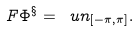<formula> <loc_0><loc_0><loc_500><loc_500>\ F { \Phi ^ { \S } } = \ u n _ { [ - \pi , \pi ] } .</formula> 